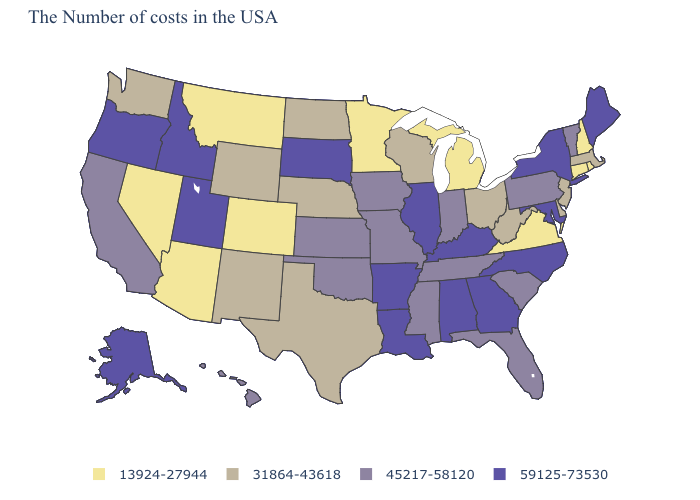Name the states that have a value in the range 45217-58120?
Answer briefly. Vermont, Pennsylvania, South Carolina, Florida, Indiana, Tennessee, Mississippi, Missouri, Iowa, Kansas, Oklahoma, California, Hawaii. What is the value of Arkansas?
Be succinct. 59125-73530. What is the highest value in the USA?
Keep it brief. 59125-73530. What is the value of Illinois?
Be succinct. 59125-73530. Name the states that have a value in the range 31864-43618?
Concise answer only. Massachusetts, New Jersey, Delaware, West Virginia, Ohio, Wisconsin, Nebraska, Texas, North Dakota, Wyoming, New Mexico, Washington. What is the highest value in states that border Nebraska?
Short answer required. 59125-73530. Does Alabama have the same value as North Carolina?
Be succinct. Yes. Does Massachusetts have a lower value than Michigan?
Short answer required. No. Name the states that have a value in the range 31864-43618?
Quick response, please. Massachusetts, New Jersey, Delaware, West Virginia, Ohio, Wisconsin, Nebraska, Texas, North Dakota, Wyoming, New Mexico, Washington. What is the lowest value in the West?
Answer briefly. 13924-27944. Name the states that have a value in the range 45217-58120?
Quick response, please. Vermont, Pennsylvania, South Carolina, Florida, Indiana, Tennessee, Mississippi, Missouri, Iowa, Kansas, Oklahoma, California, Hawaii. Which states hav the highest value in the West?
Be succinct. Utah, Idaho, Oregon, Alaska. Does Washington have the highest value in the West?
Give a very brief answer. No. Among the states that border New Jersey , which have the lowest value?
Quick response, please. Delaware. Name the states that have a value in the range 59125-73530?
Answer briefly. Maine, New York, Maryland, North Carolina, Georgia, Kentucky, Alabama, Illinois, Louisiana, Arkansas, South Dakota, Utah, Idaho, Oregon, Alaska. 